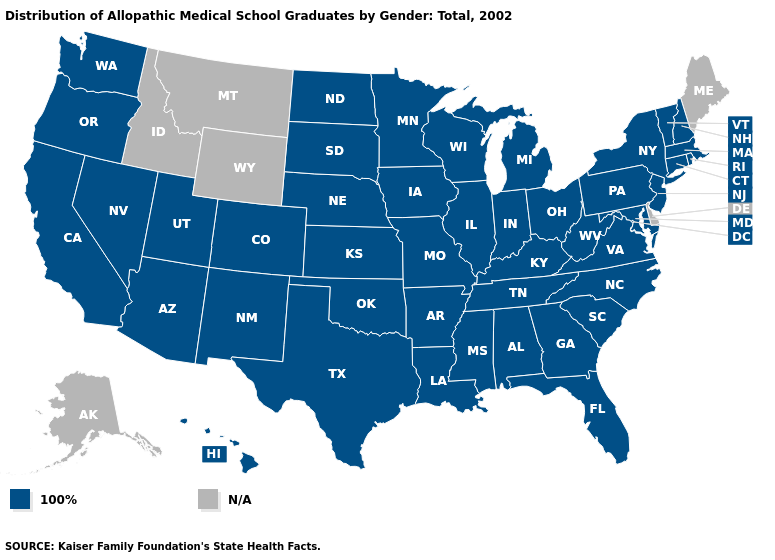Name the states that have a value in the range 100%?
Concise answer only. Alabama, Arizona, Arkansas, California, Colorado, Connecticut, Florida, Georgia, Hawaii, Illinois, Indiana, Iowa, Kansas, Kentucky, Louisiana, Maryland, Massachusetts, Michigan, Minnesota, Mississippi, Missouri, Nebraska, Nevada, New Hampshire, New Jersey, New Mexico, New York, North Carolina, North Dakota, Ohio, Oklahoma, Oregon, Pennsylvania, Rhode Island, South Carolina, South Dakota, Tennessee, Texas, Utah, Vermont, Virginia, Washington, West Virginia, Wisconsin. Name the states that have a value in the range 100%?
Give a very brief answer. Alabama, Arizona, Arkansas, California, Colorado, Connecticut, Florida, Georgia, Hawaii, Illinois, Indiana, Iowa, Kansas, Kentucky, Louisiana, Maryland, Massachusetts, Michigan, Minnesota, Mississippi, Missouri, Nebraska, Nevada, New Hampshire, New Jersey, New Mexico, New York, North Carolina, North Dakota, Ohio, Oklahoma, Oregon, Pennsylvania, Rhode Island, South Carolina, South Dakota, Tennessee, Texas, Utah, Vermont, Virginia, Washington, West Virginia, Wisconsin. Name the states that have a value in the range 100%?
Be succinct. Alabama, Arizona, Arkansas, California, Colorado, Connecticut, Florida, Georgia, Hawaii, Illinois, Indiana, Iowa, Kansas, Kentucky, Louisiana, Maryland, Massachusetts, Michigan, Minnesota, Mississippi, Missouri, Nebraska, Nevada, New Hampshire, New Jersey, New Mexico, New York, North Carolina, North Dakota, Ohio, Oklahoma, Oregon, Pennsylvania, Rhode Island, South Carolina, South Dakota, Tennessee, Texas, Utah, Vermont, Virginia, Washington, West Virginia, Wisconsin. What is the value of Massachusetts?
Be succinct. 100%. What is the highest value in the USA?
Short answer required. 100%. What is the lowest value in the MidWest?
Keep it brief. 100%. Name the states that have a value in the range N/A?
Answer briefly. Alaska, Delaware, Idaho, Maine, Montana, Wyoming. Name the states that have a value in the range 100%?
Short answer required. Alabama, Arizona, Arkansas, California, Colorado, Connecticut, Florida, Georgia, Hawaii, Illinois, Indiana, Iowa, Kansas, Kentucky, Louisiana, Maryland, Massachusetts, Michigan, Minnesota, Mississippi, Missouri, Nebraska, Nevada, New Hampshire, New Jersey, New Mexico, New York, North Carolina, North Dakota, Ohio, Oklahoma, Oregon, Pennsylvania, Rhode Island, South Carolina, South Dakota, Tennessee, Texas, Utah, Vermont, Virginia, Washington, West Virginia, Wisconsin. Which states have the lowest value in the USA?
Keep it brief. Alabama, Arizona, Arkansas, California, Colorado, Connecticut, Florida, Georgia, Hawaii, Illinois, Indiana, Iowa, Kansas, Kentucky, Louisiana, Maryland, Massachusetts, Michigan, Minnesota, Mississippi, Missouri, Nebraska, Nevada, New Hampshire, New Jersey, New Mexico, New York, North Carolina, North Dakota, Ohio, Oklahoma, Oregon, Pennsylvania, Rhode Island, South Carolina, South Dakota, Tennessee, Texas, Utah, Vermont, Virginia, Washington, West Virginia, Wisconsin. What is the lowest value in the MidWest?
Be succinct. 100%. What is the highest value in the Northeast ?
Write a very short answer. 100%. Does the first symbol in the legend represent the smallest category?
Short answer required. Yes. 